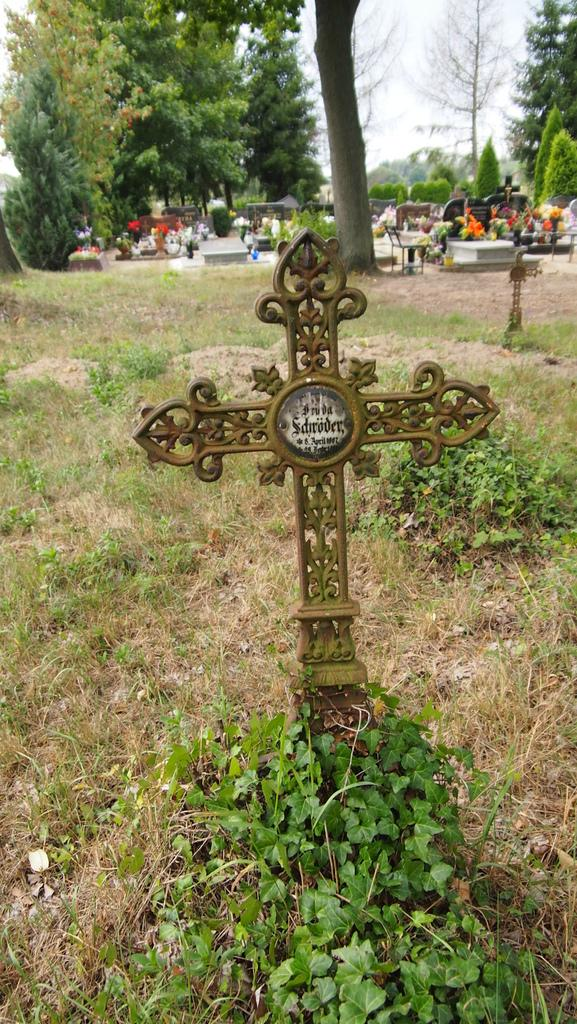What type of vegetation is present in the image? There is grass in the image. What is the main subject of the image? There is a graveyard in the image. What can be seen in the background of the image? There are trees and the sky visible in the background of the image. How many beetles can be seen flying in the air in the image? There are no beetles visible in the image, and the air is not mentioned as a subject in the provided facts. 